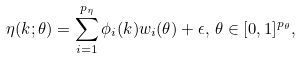Convert formula to latex. <formula><loc_0><loc_0><loc_500><loc_500>\eta ( k ; \theta ) = \sum _ { i = 1 } ^ { p _ { \eta } } \phi _ { i } ( k ) w _ { i } ( \theta ) + \epsilon , \, \theta \in [ 0 , 1 ] ^ { p _ { \theta } } ,</formula> 